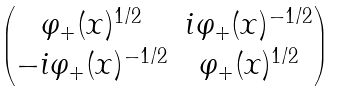Convert formula to latex. <formula><loc_0><loc_0><loc_500><loc_500>\begin{pmatrix} \varphi _ { + } ( x ) ^ { 1 / 2 } & i \varphi _ { + } ( x ) ^ { - 1 / 2 } \\ - i \varphi _ { + } ( x ) ^ { - 1 / 2 } & \varphi _ { + } ( x ) ^ { 1 / 2 } \end{pmatrix}</formula> 